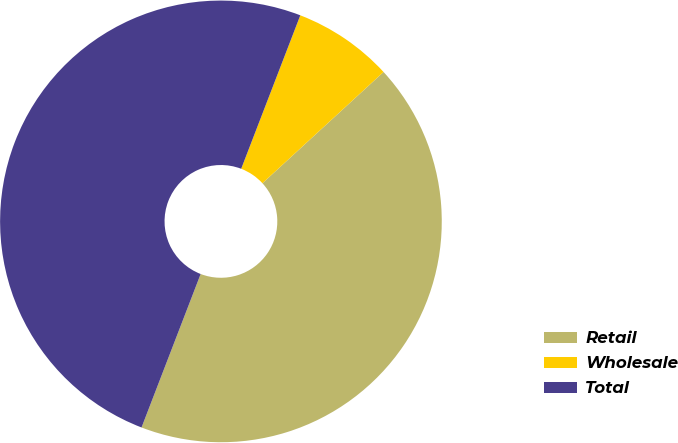Convert chart to OTSL. <chart><loc_0><loc_0><loc_500><loc_500><pie_chart><fcel>Retail<fcel>Wholesale<fcel>Total<nl><fcel>42.68%<fcel>7.32%<fcel>50.0%<nl></chart> 